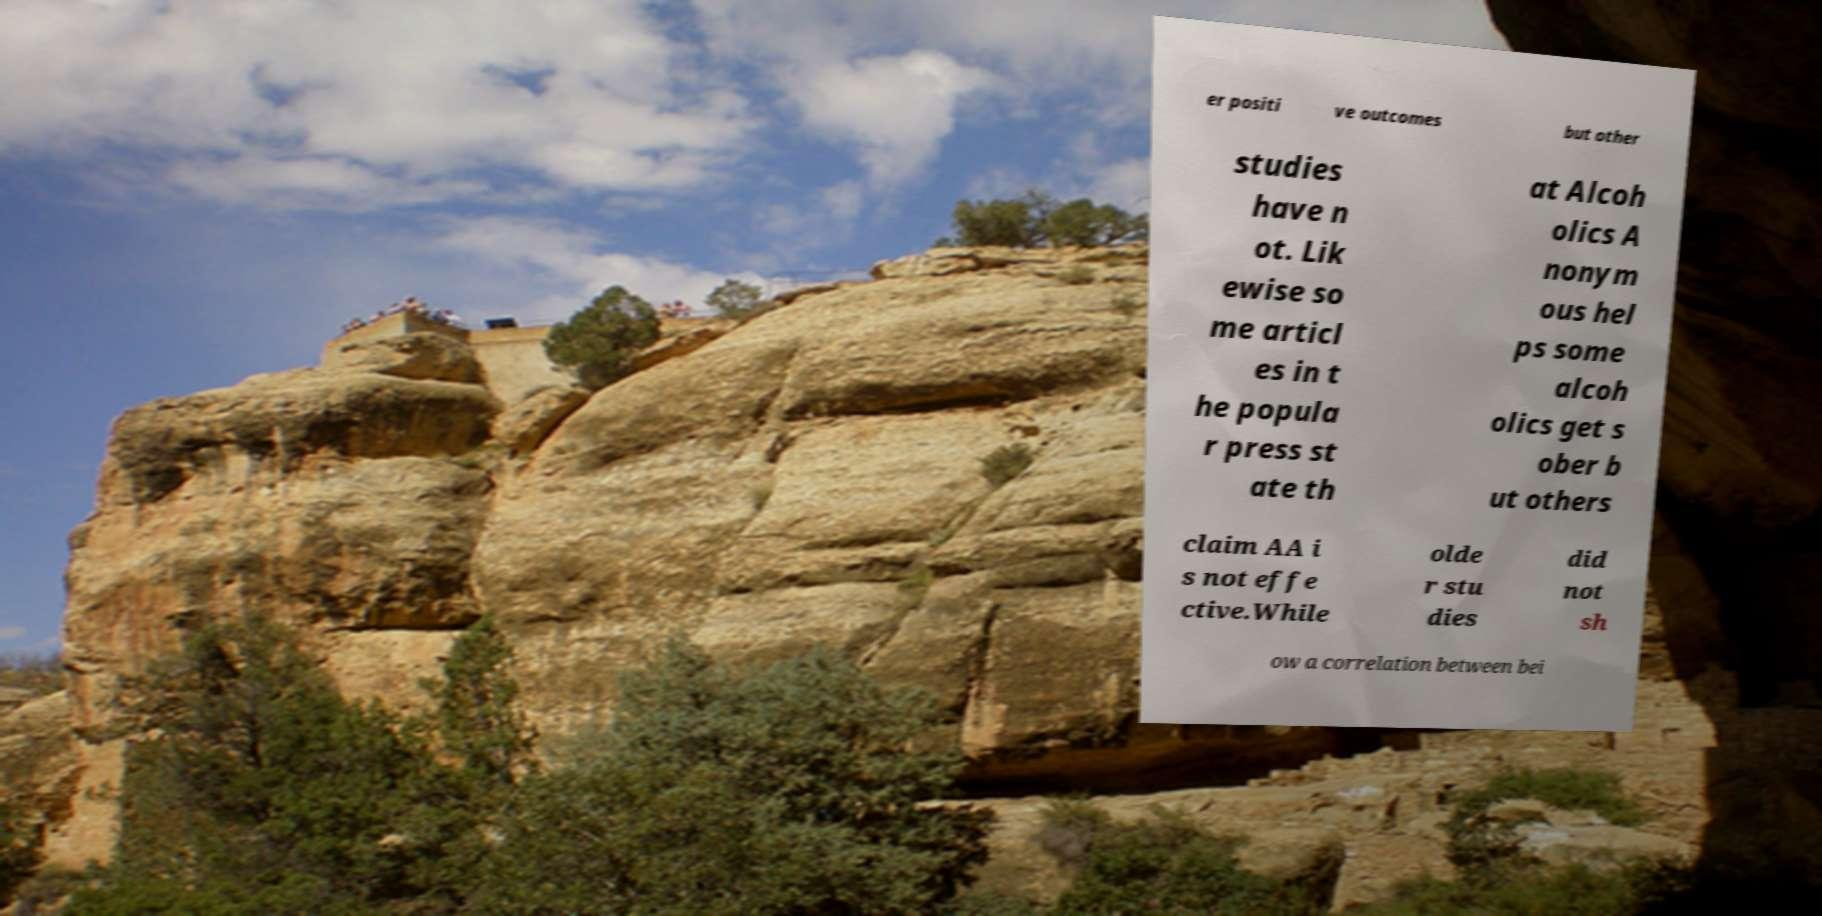For documentation purposes, I need the text within this image transcribed. Could you provide that? er positi ve outcomes but other studies have n ot. Lik ewise so me articl es in t he popula r press st ate th at Alcoh olics A nonym ous hel ps some alcoh olics get s ober b ut others claim AA i s not effe ctive.While olde r stu dies did not sh ow a correlation between bei 